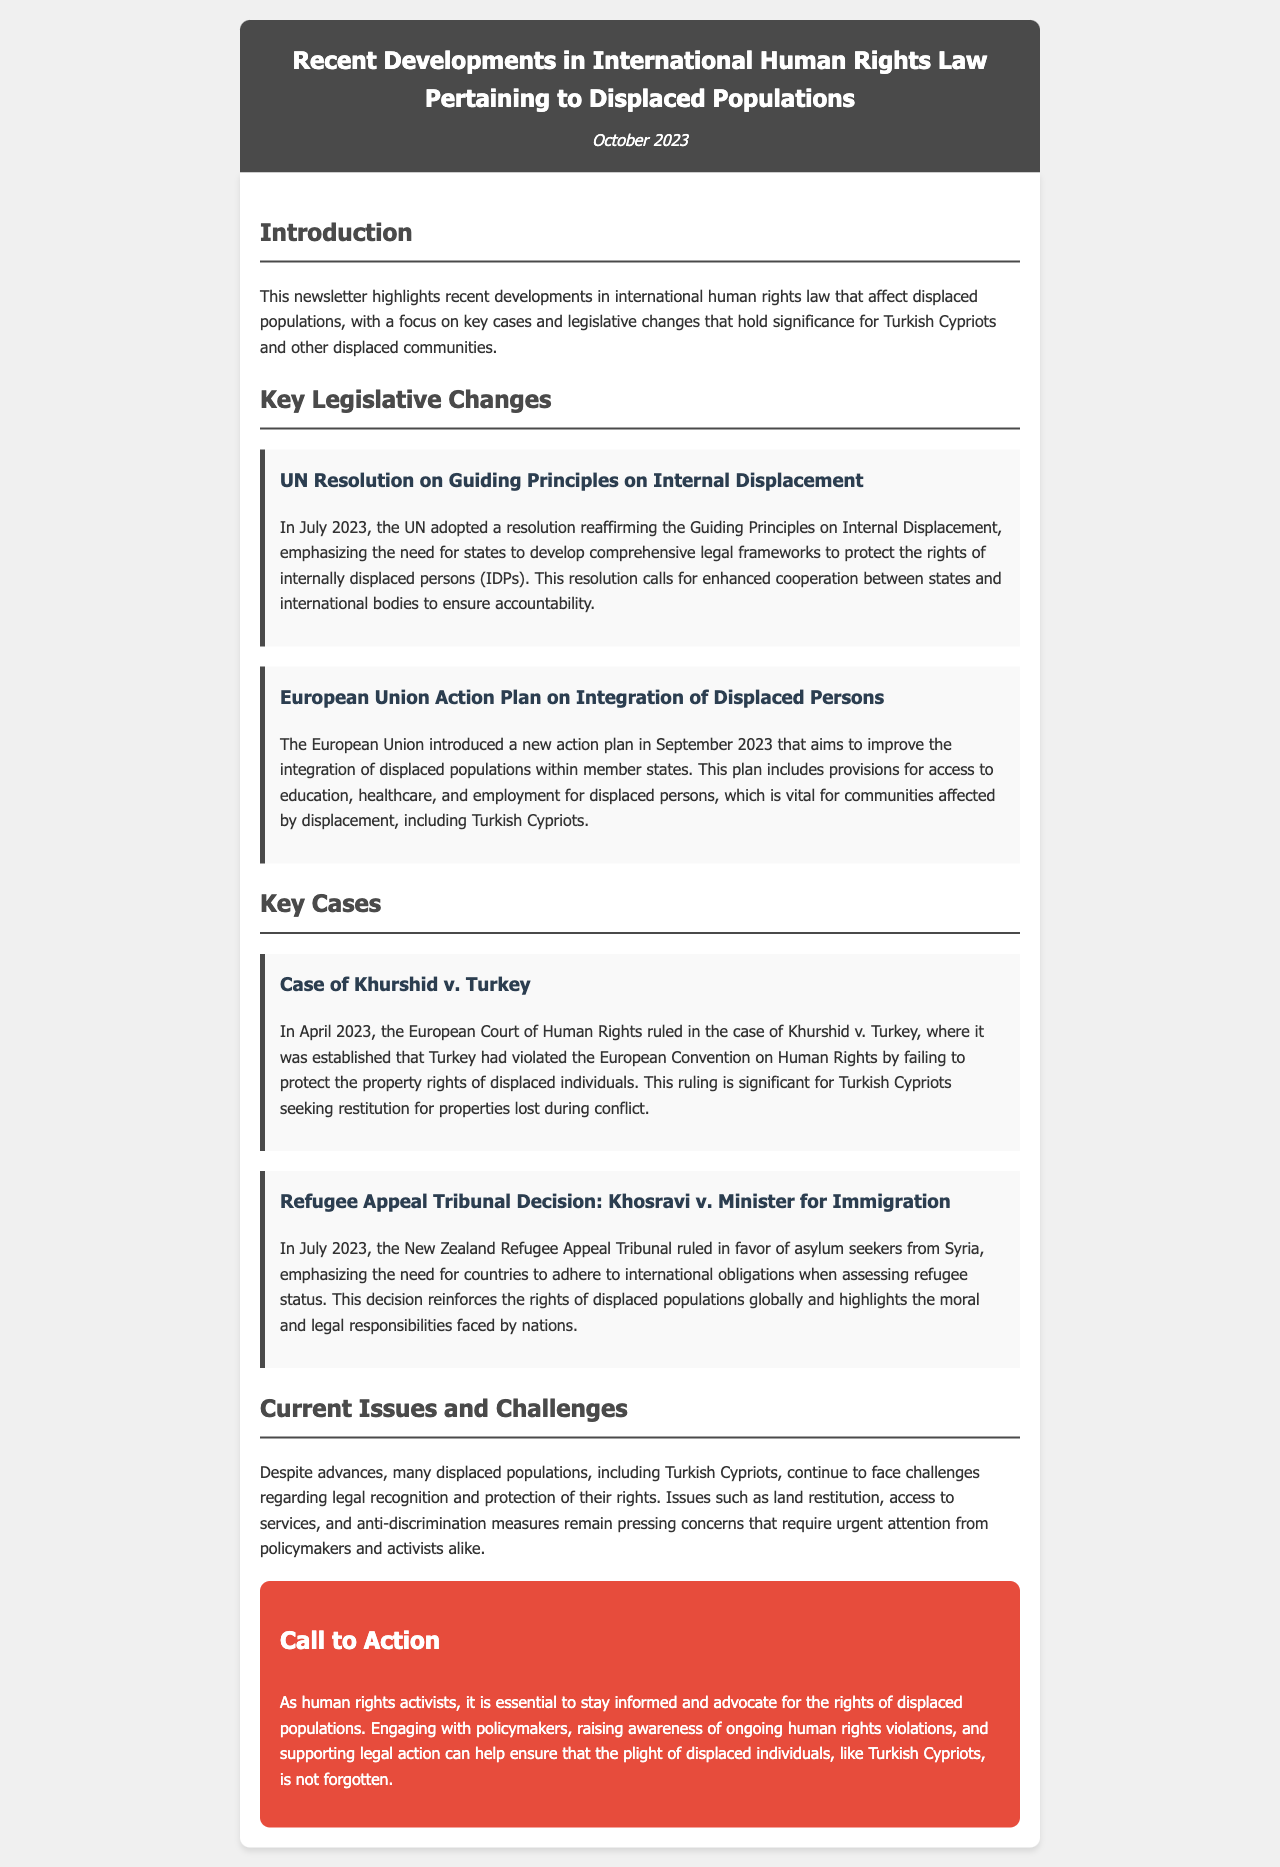What resolution did the UN adopt in July 2023? The resolution reaffirmed the Guiding Principles on Internal Displacement, emphasizing the need for states to develop comprehensive legal frameworks to protect the rights of internally displaced persons.
Answer: Guiding Principles on Internal Displacement When was the EU Action Plan on Integration of Displaced Persons introduced? The document states that the action plan was introduced in September 2023.
Answer: September 2023 What was the ruling of the European Court of Human Rights in the case of Khurshid v. Turkey? The ruling established that Turkey had violated the European Convention on Human Rights by failing to protect the property rights of displaced individuals.
Answer: Violation of property rights What ongoing issues do displaced populations, including Turkish Cypriots, face? The document highlights issues such as land restitution, access to services, and anti-discrimination measures.
Answer: Land restitution, access to services, anti-discrimination measures What is the call to action for human rights activists? The call to action emphasizes the importance of staying informed and advocating for the rights of displaced populations.
Answer: Stay informed and advocate for rights 